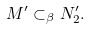Convert formula to latex. <formula><loc_0><loc_0><loc_500><loc_500>M ^ { \prime } \subset _ { \beta } N _ { 2 } ^ { \prime } .</formula> 